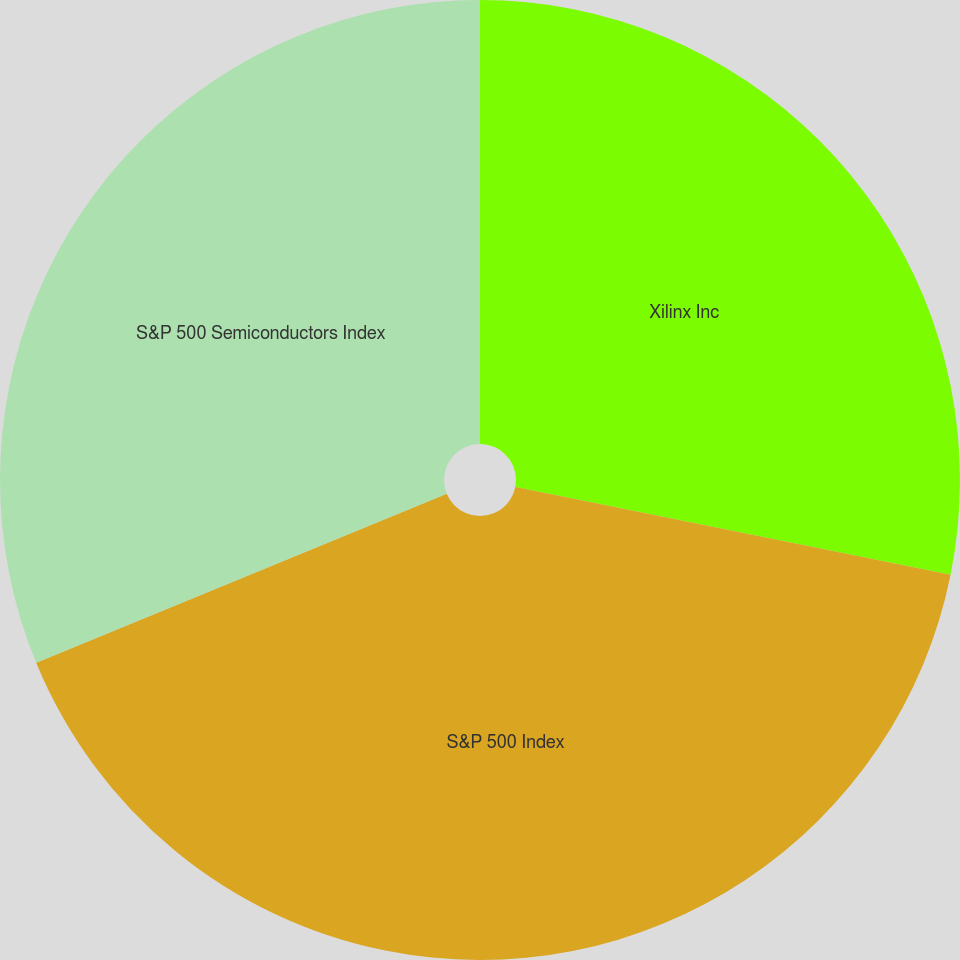Convert chart to OTSL. <chart><loc_0><loc_0><loc_500><loc_500><pie_chart><fcel>Xilinx Inc<fcel>S&P 500 Index<fcel>S&P 500 Semiconductors Index<nl><fcel>28.16%<fcel>40.62%<fcel>31.22%<nl></chart> 